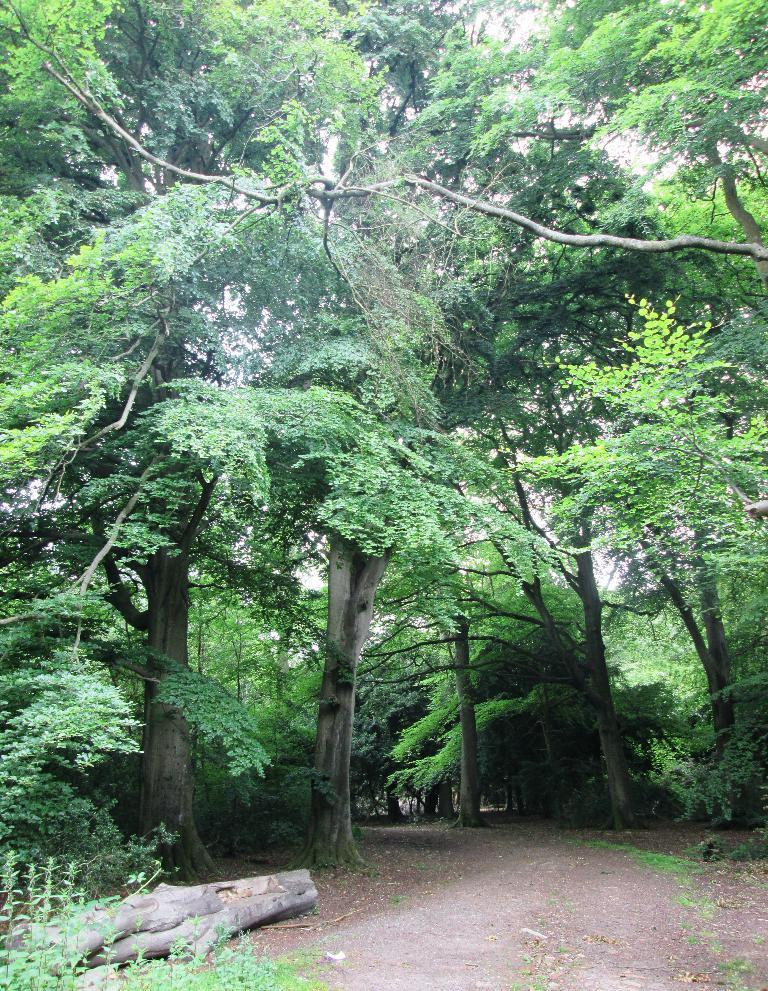What type of vegetation can be seen in the image? There are trees and plants visible in the image. What object can be seen in the image that is typically used for storing or transporting items? There is a trunk in the image. Where are the plants located in the image? The plants are towards the left side of the image. What type of ground cover is visible in the image? There is grass visible in the image. What arithmetic problem is being solved by the cows in the image? There are no cows present in the image, and therefore no arithmetic problem is being solved. How does the earthquake affect the trees in the image? There is no earthquake present in the image, so the trees are not affected by one. 